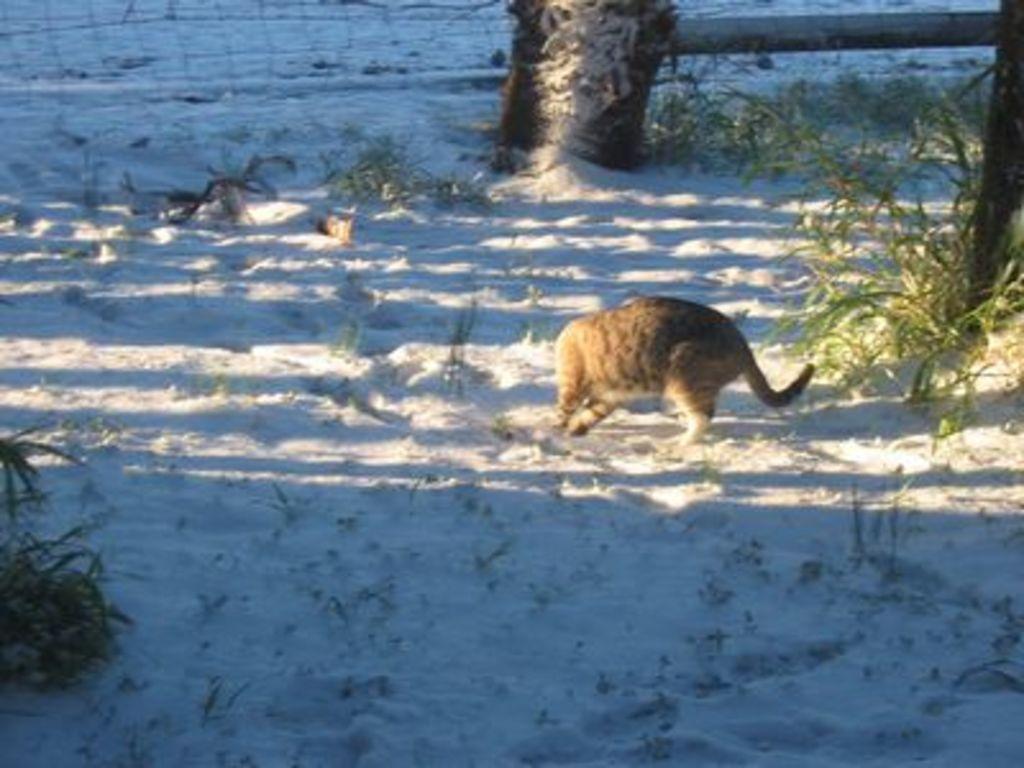How would you summarize this image in a sentence or two? In this image I can see an animal which is in brown color. Background I can see few plants in green color and I can also see a railing. 